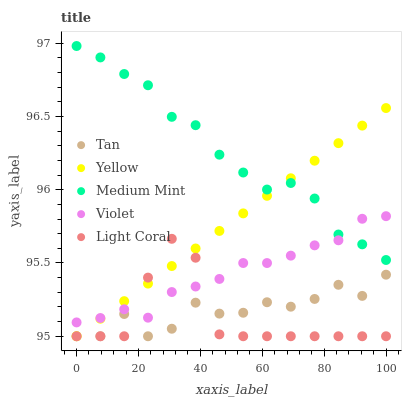Does Light Coral have the minimum area under the curve?
Answer yes or no. Yes. Does Medium Mint have the maximum area under the curve?
Answer yes or no. Yes. Does Tan have the minimum area under the curve?
Answer yes or no. No. Does Tan have the maximum area under the curve?
Answer yes or no. No. Is Yellow the smoothest?
Answer yes or no. Yes. Is Light Coral the roughest?
Answer yes or no. Yes. Is Tan the smoothest?
Answer yes or no. No. Is Tan the roughest?
Answer yes or no. No. Does Light Coral have the lowest value?
Answer yes or no. Yes. Does Violet have the lowest value?
Answer yes or no. No. Does Medium Mint have the highest value?
Answer yes or no. Yes. Does Light Coral have the highest value?
Answer yes or no. No. Is Light Coral less than Medium Mint?
Answer yes or no. Yes. Is Violet greater than Tan?
Answer yes or no. Yes. Does Light Coral intersect Yellow?
Answer yes or no. Yes. Is Light Coral less than Yellow?
Answer yes or no. No. Is Light Coral greater than Yellow?
Answer yes or no. No. Does Light Coral intersect Medium Mint?
Answer yes or no. No. 